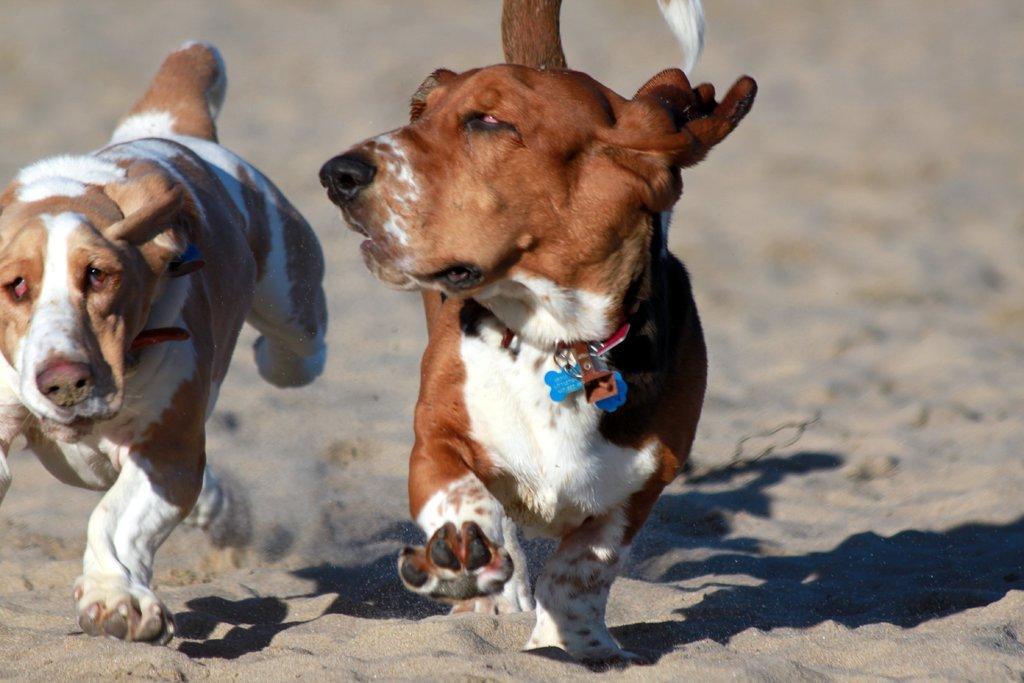In one or two sentences, can you explain what this image depicts? There are two dogs walking. This looks like a sand. I think this is the dog belt, which is around its neck. 